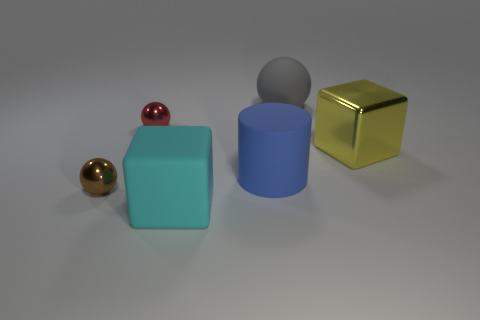Are there any red shiny things of the same shape as the cyan thing?
Provide a succinct answer. No. What is the shape of the blue rubber thing in front of the rubber sphere that is to the right of the blue matte cylinder?
Offer a terse response. Cylinder. The big object that is to the right of the big gray matte sphere has what shape?
Provide a succinct answer. Cube. Do the sphere that is on the right side of the cyan rubber object and the big cube that is in front of the brown metal object have the same color?
Offer a very short reply. No. How many balls are both in front of the big ball and to the right of the brown metal ball?
Your answer should be very brief. 1. There is a yellow thing that is made of the same material as the small brown sphere; what is its size?
Keep it short and to the point. Large. How big is the matte cylinder?
Ensure brevity in your answer.  Large. What is the small brown sphere made of?
Keep it short and to the point. Metal. There is a brown object that is behind the cyan rubber thing; is its size the same as the cyan thing?
Ensure brevity in your answer.  No. How many objects are large matte balls or large metal things?
Your response must be concise. 2. 